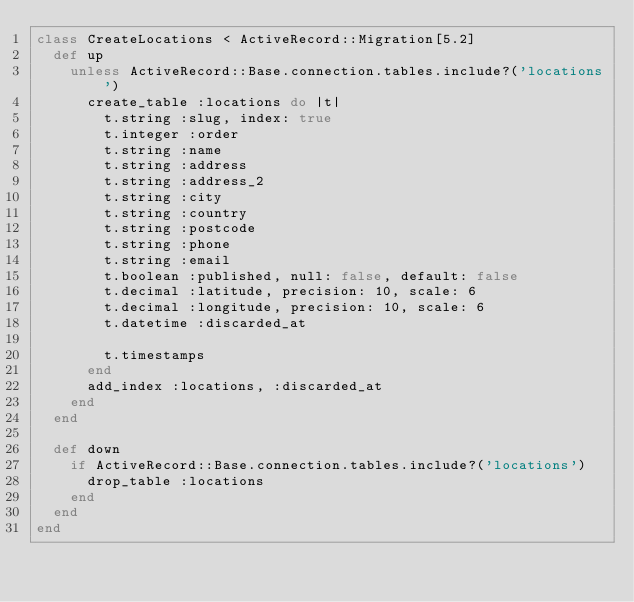Convert code to text. <code><loc_0><loc_0><loc_500><loc_500><_Ruby_>class CreateLocations < ActiveRecord::Migration[5.2]
  def up
    unless ActiveRecord::Base.connection.tables.include?('locations')
      create_table :locations do |t|
        t.string :slug, index: true
        t.integer :order
        t.string :name
        t.string :address
        t.string :address_2
        t.string :city
        t.string :country
        t.string :postcode
        t.string :phone
        t.string :email
        t.boolean :published, null: false, default: false
        t.decimal :latitude, precision: 10, scale: 6
        t.decimal :longitude, precision: 10, scale: 6
        t.datetime :discarded_at

        t.timestamps
      end
      add_index :locations, :discarded_at
    end
  end

  def down
    if ActiveRecord::Base.connection.tables.include?('locations')
      drop_table :locations
    end
  end
end
</code> 